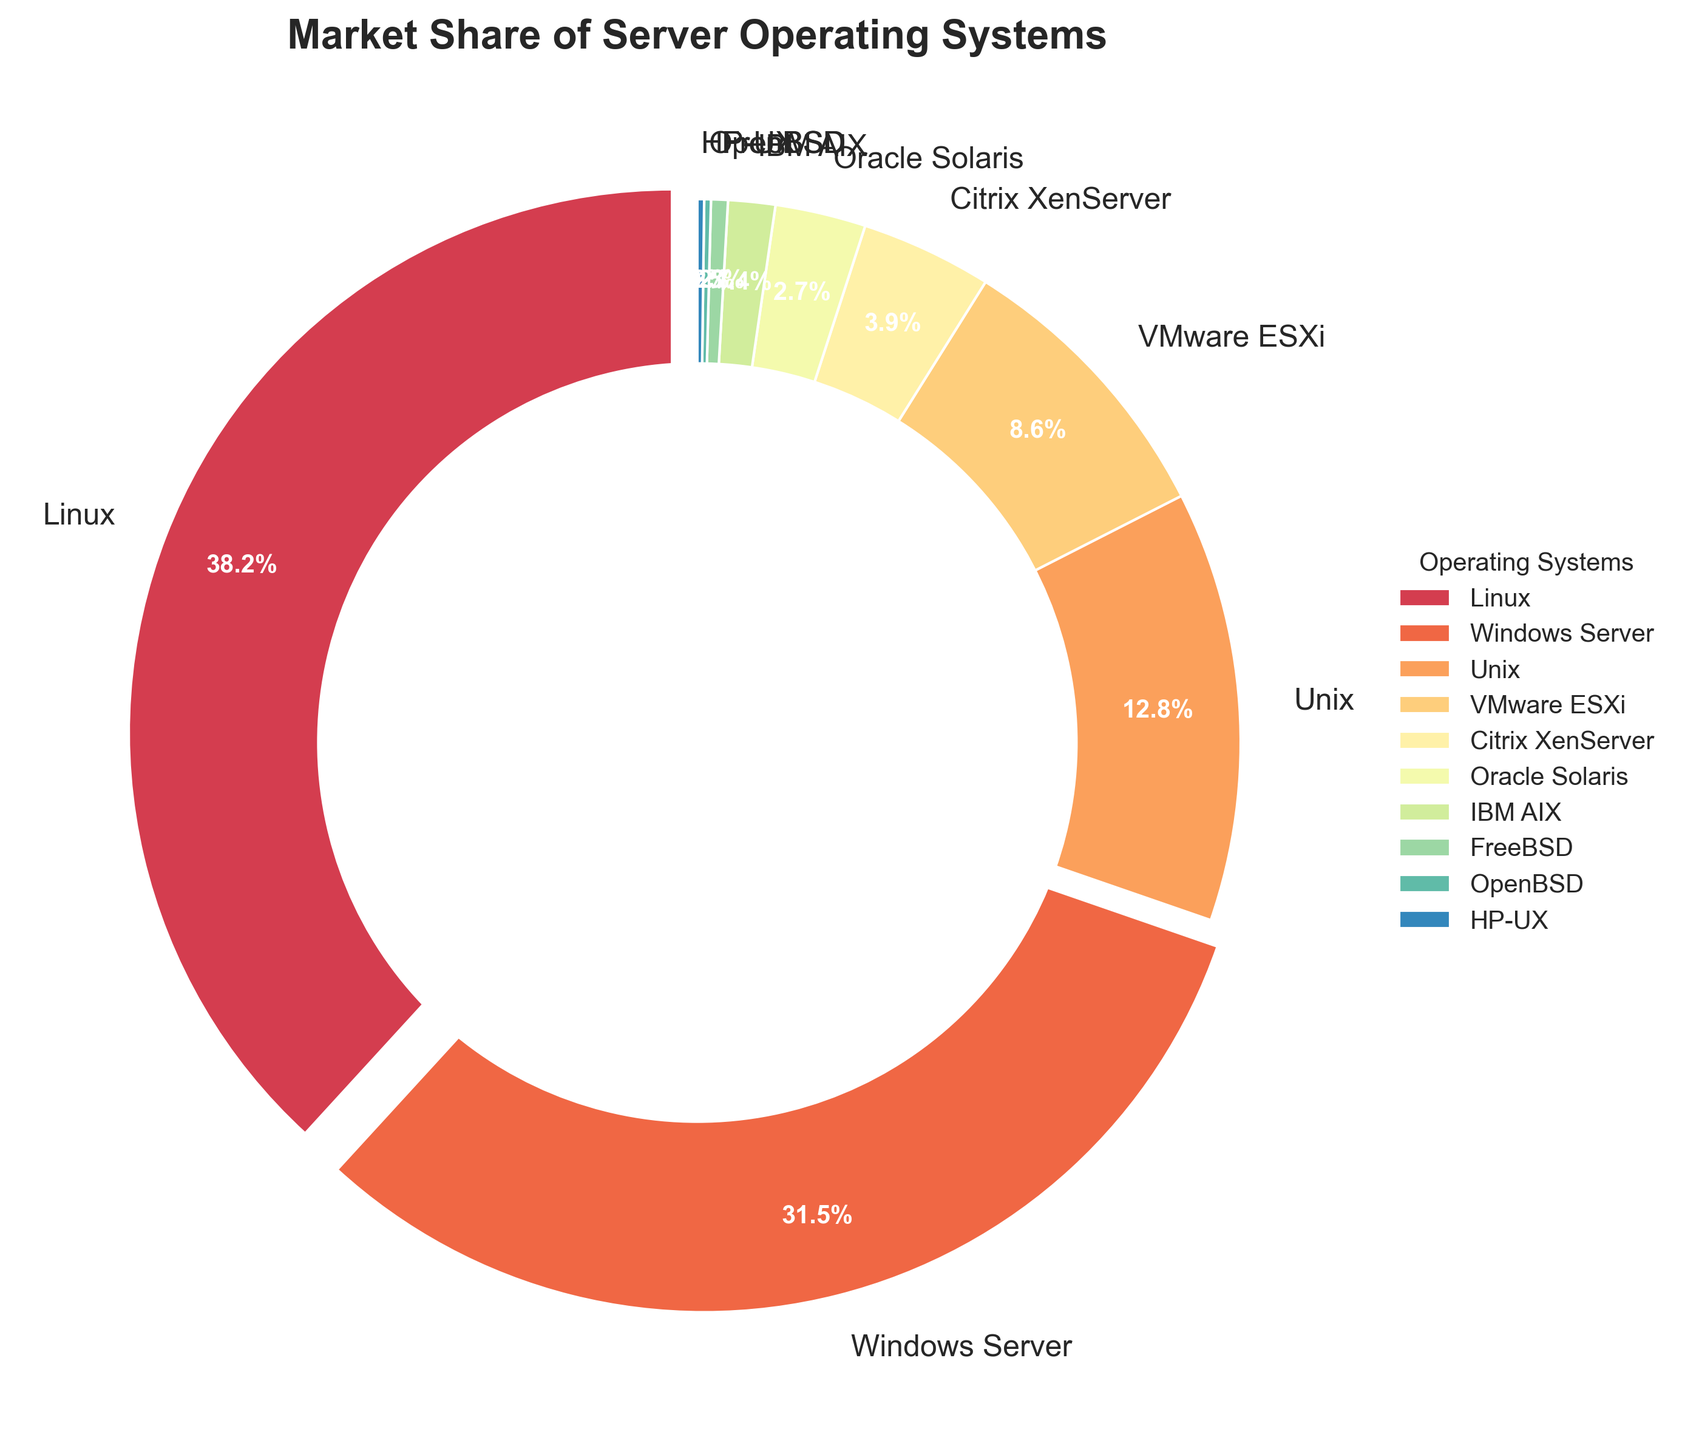What's the largest market share for server operating systems? Linux has a market share of 38.2%, which is the largest among all other operating systems. This can be seen as the largest wedge in the pie chart labeled "Linux".
Answer: 38.2% Which operating systems have a market share greater than 10%? From the pie chart, Linux (38.2%), Windows Server (31.5%), and Unix (12.8%) all have a market share greater than 10%. These segments are larger than others and explicitly labeled with their percentages.
Answer: Linux, Windows Server, Unix Which operating systems are under 1% market share? The operating systems with market shares under 1% in the pie chart are FreeBSD (0.5%), OpenBSD (0.2%), and HP-UX (0.2%). Their wedges are tiny and have the percentages labeled within them.
Answer: FreeBSD, OpenBSD, HP-UX What is the difference in market share between the top two operating systems? The top two operating systems are Linux (38.2%) and Windows Server (31.5%). The difference is calculated as 38.2% - 31.5% = 6.7%.
Answer: 6.7% Which section of the pie chart is highlighted or exploded? Only the Linux segment is slightly separated from the rest of the pie chart. This visual emphasis indicates its market share is above 30%.
Answer: Linux What is the combined market share of Unix-based systems (Linux, Unix, Oracle Solaris, FreeBSD, OpenBSD, HP-UX)? Summing up the market shares: Linux (38.2%) + Unix (12.8%) + Oracle Solaris (2.7%) + FreeBSD (0.5%) + OpenBSD (0.2%) + HP-UX (0.2%) = 54.6%.
Answer: 54.6% Which operating system has just above 3% but less than 4% market share? Citrix XenServer has a market share of 3.9%, which falls between 3% and 4%. This can be identified by the corresponding labeled wedge in the pie chart.
Answer: Citrix XenServer What color is used for the VMware ESXi segment? The VMware ESXi segment is represented by a shade of color in the pink spectrum, which can be visually identified on the pie chart.
Answer: Pink How many operating systems have less than a 5% market share? The operating systems with less than a 5% market share are Citrix XenServer, Oracle Solaris, IBM AIX, FreeBSD, OpenBSD, and HP-UX. This totals 6 systems.
Answer: 6 What is the market share difference between Unix and IBM AIX? Unix has a market share of 12.8%, while IBM AIX has a market share of 1.4%. The difference is calculated as 12.8% - 1.4% = 11.4%.
Answer: 11.4% 